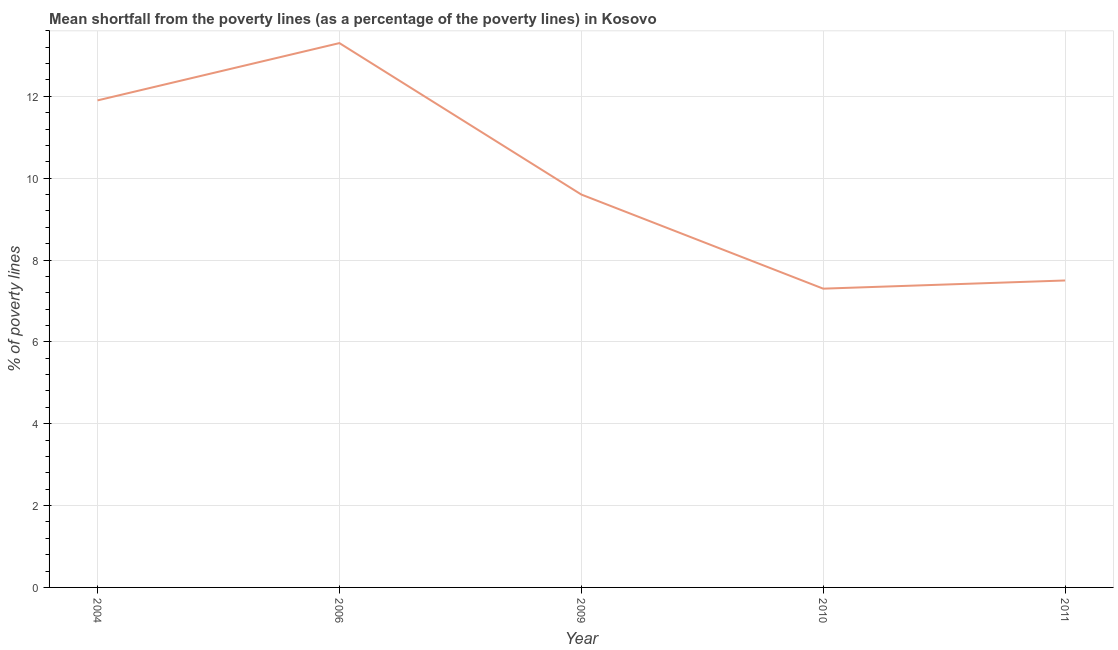In which year was the poverty gap at national poverty lines maximum?
Make the answer very short. 2006. What is the sum of the poverty gap at national poverty lines?
Make the answer very short. 49.6. What is the difference between the poverty gap at national poverty lines in 2004 and 2006?
Provide a succinct answer. -1.4. What is the average poverty gap at national poverty lines per year?
Give a very brief answer. 9.92. In how many years, is the poverty gap at national poverty lines greater than 10 %?
Your answer should be very brief. 2. What is the ratio of the poverty gap at national poverty lines in 2004 to that in 2010?
Your response must be concise. 1.63. Is the poverty gap at national poverty lines in 2009 less than that in 2010?
Provide a short and direct response. No. Is the difference between the poverty gap at national poverty lines in 2004 and 2009 greater than the difference between any two years?
Provide a short and direct response. No. What is the difference between the highest and the second highest poverty gap at national poverty lines?
Make the answer very short. 1.4. What is the difference between the highest and the lowest poverty gap at national poverty lines?
Make the answer very short. 6. How many years are there in the graph?
Offer a very short reply. 5. What is the difference between two consecutive major ticks on the Y-axis?
Provide a short and direct response. 2. Does the graph contain any zero values?
Your response must be concise. No. What is the title of the graph?
Keep it short and to the point. Mean shortfall from the poverty lines (as a percentage of the poverty lines) in Kosovo. What is the label or title of the Y-axis?
Your response must be concise. % of poverty lines. What is the % of poverty lines in 2009?
Your answer should be very brief. 9.6. What is the % of poverty lines of 2010?
Keep it short and to the point. 7.3. What is the % of poverty lines of 2011?
Your response must be concise. 7.5. What is the difference between the % of poverty lines in 2006 and 2009?
Ensure brevity in your answer.  3.7. What is the difference between the % of poverty lines in 2006 and 2011?
Give a very brief answer. 5.8. What is the difference between the % of poverty lines in 2009 and 2011?
Offer a very short reply. 2.1. What is the difference between the % of poverty lines in 2010 and 2011?
Your answer should be very brief. -0.2. What is the ratio of the % of poverty lines in 2004 to that in 2006?
Ensure brevity in your answer.  0.9. What is the ratio of the % of poverty lines in 2004 to that in 2009?
Keep it short and to the point. 1.24. What is the ratio of the % of poverty lines in 2004 to that in 2010?
Ensure brevity in your answer.  1.63. What is the ratio of the % of poverty lines in 2004 to that in 2011?
Provide a short and direct response. 1.59. What is the ratio of the % of poverty lines in 2006 to that in 2009?
Give a very brief answer. 1.39. What is the ratio of the % of poverty lines in 2006 to that in 2010?
Provide a short and direct response. 1.82. What is the ratio of the % of poverty lines in 2006 to that in 2011?
Provide a succinct answer. 1.77. What is the ratio of the % of poverty lines in 2009 to that in 2010?
Keep it short and to the point. 1.31. What is the ratio of the % of poverty lines in 2009 to that in 2011?
Provide a short and direct response. 1.28. What is the ratio of the % of poverty lines in 2010 to that in 2011?
Provide a succinct answer. 0.97. 